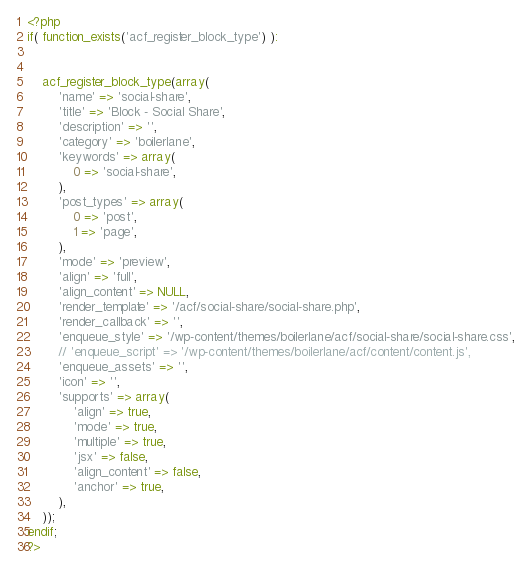Convert code to text. <code><loc_0><loc_0><loc_500><loc_500><_PHP_><?php
if( function_exists('acf_register_block_type') ):

    
    acf_register_block_type(array(
        'name' => 'social-share',
        'title' => 'Block - Social Share',
        'description' => '',
        'category' => 'boilerlane',
        'keywords' => array(
            0 => 'social-share',
        ),
        'post_types' => array(
            0 => 'post',
            1 => 'page',
        ),
        'mode' => 'preview',
        'align' => 'full',
        'align_content' => NULL,
        'render_template' => '/acf/social-share/social-share.php',
        'render_callback' => '',
        'enqueue_style' => '/wp-content/themes/boilerlane/acf/social-share/social-share.css',
        // 'enqueue_script' => '/wp-content/themes/boilerlane/acf/content/content.js',
        'enqueue_assets' => '',
        'icon' => '',
        'supports' => array(
            'align' => true,
            'mode' => true,
            'multiple' => true,
            'jsx' => false,
            'align_content' => false,
            'anchor' => true,
        ),
    ));
endif;
?></code> 